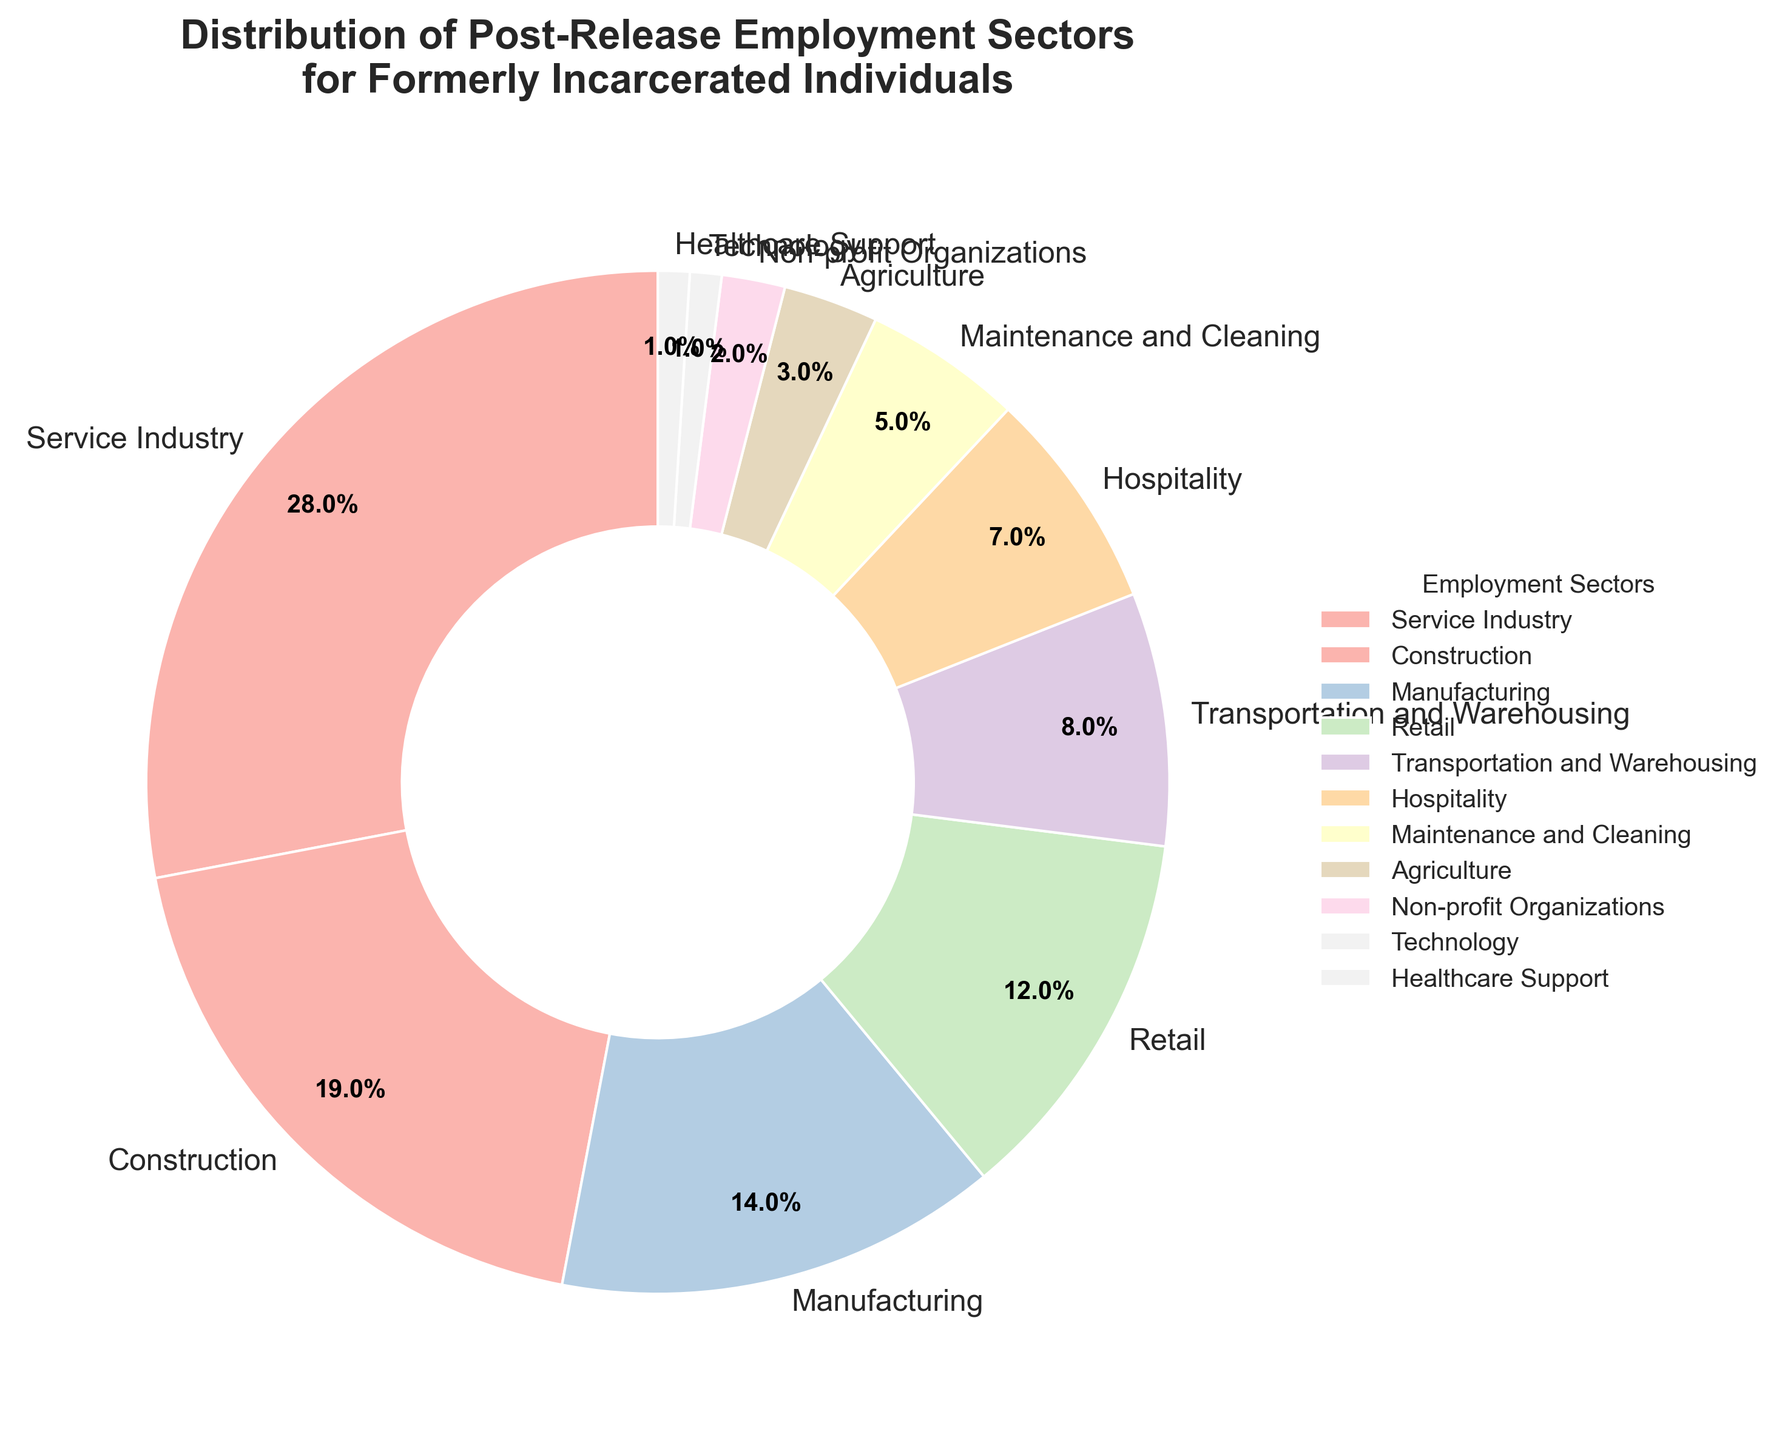What is the percentage of formerly incarcerated individuals employed in the Service Industry? According to the pie chart, the section labeled "Service Industry" accounts for 28% of the distribution.
Answer: 28% Which sector employs more individuals: Manufacturing or Transportation and Warehousing? By comparing the two sectors, the pie chart shows that Manufacturing employs 14% while Transportation and Warehousing employs 8%. Therefore, Manufacturing employs more individuals.
Answer: Manufacturing How much larger is the percentage of individuals employed in the Construction sector compared to the Retail sector? From the pie chart, we see that Construction employs 19% while Retail employs 12%. The difference is 19% - 12% = 7%.
Answer: 7% What is the combined percentage of individuals working in the Maintenance and Cleaning and Agriculture sectors? The pie chart shows 5% for Maintenance and Cleaning and 3% for Agriculture. Adding these, we get 5% + 3% = 8%.
Answer: 8% Are there more individuals employed in Non-profit Organizations or Healthcare Support? The pie chart indicates that Non-profit Organizations employ 2% and Healthcare Support employs 1%. Thus, more individuals are employed in Non-profit Organizations.
Answer: Non-profit Organizations Which sector employs the fewest individuals? The pie chart shows the smallest slice labeled "Technology," which accounts for just 1%.
Answer: Technology What is the visual difference between the slices representing Hospitality and Technology sectors? The slice for Hospitality is visibly larger and occupies 7% of the pie chart, whereas the slice for Technology is much smaller, occupying only 1%.
Answer: Hospitality is larger What is the total percentage of individuals employed in the top three sectors? The top three sectors by percentage are Service Industry (28%), Construction (19%), and Manufacturing (14%). Adding these, we get 28% + 19% + 14% = 61%.
Answer: 61% Which sectors have a percentage of employment less than or equal to 5%? The sectors with employment percentages less than or equal to 5% are Maintenance and Cleaning (5%), Agriculture (3%), Non-profit Organizations (2%), Technology (1%), and Healthcare Support (1%).
Answer: Maintenance and Cleaning, Agriculture, Non-profit Organizations, Technology, Healthcare Support What fraction of formerly incarcerated individuals are employed in the Healthcare Support and Technology sectors combined? Healthcare Support accounts for 1% and Technology also accounts for 1%, so the combined percentage is 1% + 1% = 2%. Therefore, out of 100%, 2% combined is 2/100, which simplifies to 1/50.
Answer: 1/50 